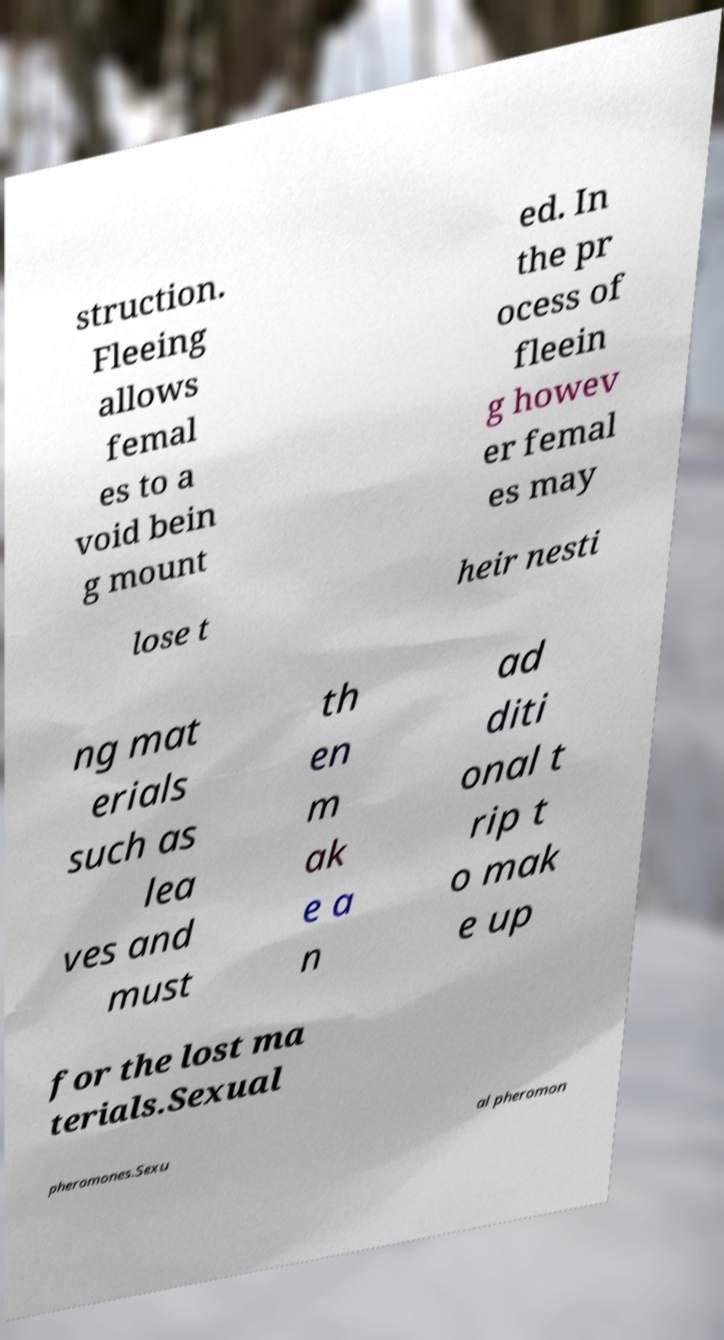Could you extract and type out the text from this image? struction. Fleeing allows femal es to a void bein g mount ed. In the pr ocess of fleein g howev er femal es may lose t heir nesti ng mat erials such as lea ves and must th en m ak e a n ad diti onal t rip t o mak e up for the lost ma terials.Sexual pheromones.Sexu al pheromon 